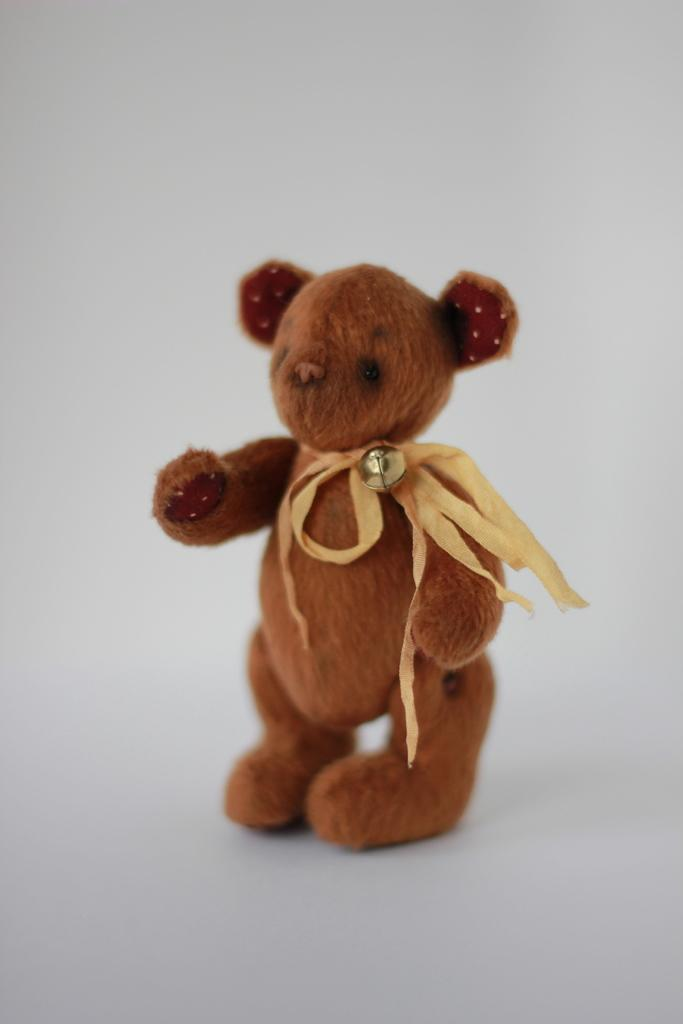What type of toy is in the image? There is a brown teddy in the image. What color is the teddy? The brown teddy is brown in color. What is the background of the image? The background of the image is white. What type of drum is the daughter playing in the image? There is no drum or daughter present in the image; it only features a brown teddy. 